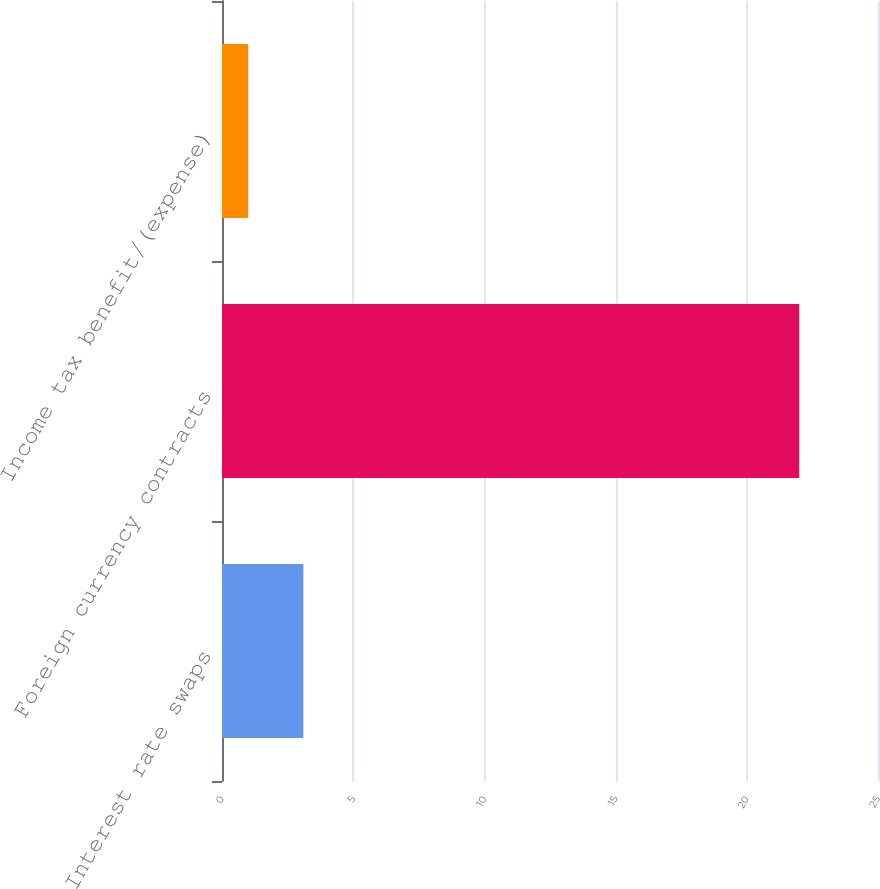Convert chart. <chart><loc_0><loc_0><loc_500><loc_500><bar_chart><fcel>Interest rate swaps<fcel>Foreign currency contracts<fcel>Income tax benefit/(expense)<nl><fcel>3.1<fcel>22<fcel>1<nl></chart> 